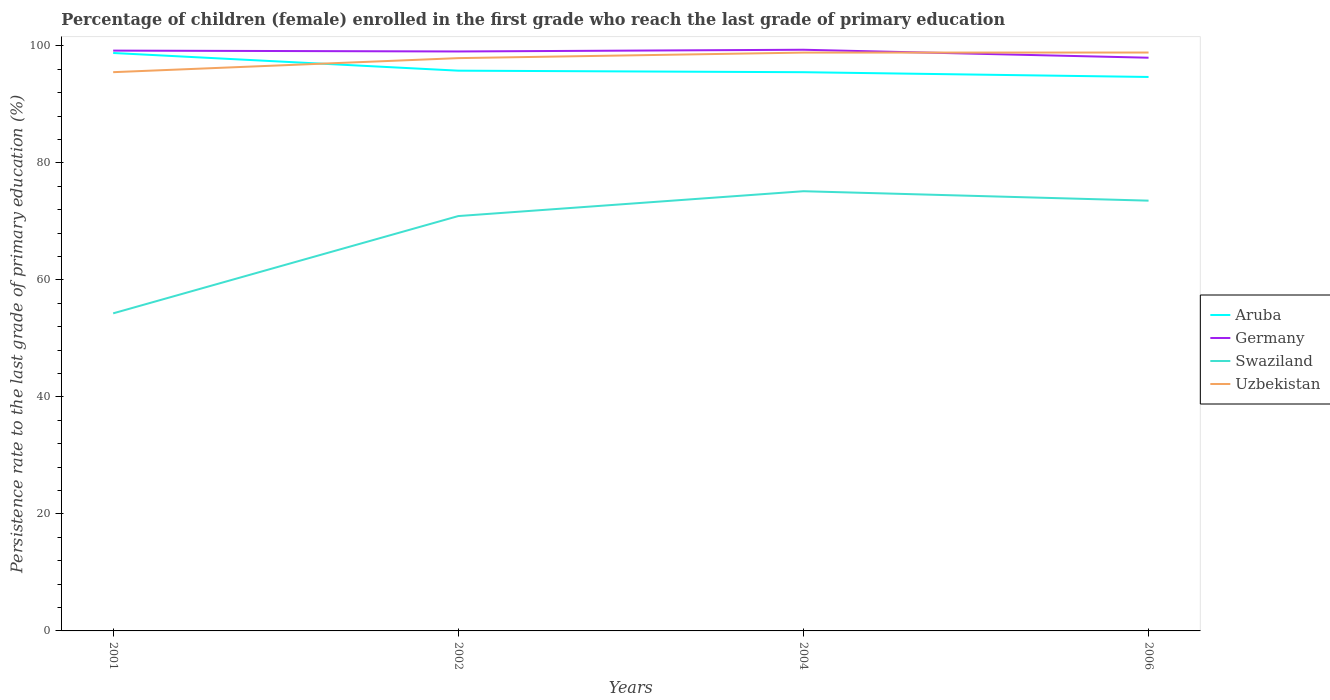Does the line corresponding to Germany intersect with the line corresponding to Aruba?
Your response must be concise. No. Is the number of lines equal to the number of legend labels?
Offer a terse response. Yes. Across all years, what is the maximum persistence rate of children in Swaziland?
Your response must be concise. 54.29. What is the total persistence rate of children in Swaziland in the graph?
Your answer should be compact. -16.63. What is the difference between the highest and the second highest persistence rate of children in Germany?
Offer a very short reply. 1.36. What is the difference between the highest and the lowest persistence rate of children in Aruba?
Ensure brevity in your answer.  1. Is the persistence rate of children in Aruba strictly greater than the persistence rate of children in Germany over the years?
Your response must be concise. Yes. How many years are there in the graph?
Your answer should be very brief. 4. What is the difference between two consecutive major ticks on the Y-axis?
Make the answer very short. 20. Are the values on the major ticks of Y-axis written in scientific E-notation?
Your answer should be compact. No. Does the graph contain any zero values?
Offer a terse response. No. Where does the legend appear in the graph?
Your response must be concise. Center right. How many legend labels are there?
Your answer should be very brief. 4. What is the title of the graph?
Ensure brevity in your answer.  Percentage of children (female) enrolled in the first grade who reach the last grade of primary education. Does "Mauritius" appear as one of the legend labels in the graph?
Give a very brief answer. No. What is the label or title of the X-axis?
Provide a succinct answer. Years. What is the label or title of the Y-axis?
Provide a succinct answer. Persistence rate to the last grade of primary education (%). What is the Persistence rate to the last grade of primary education (%) in Aruba in 2001?
Your answer should be very brief. 98.8. What is the Persistence rate to the last grade of primary education (%) in Germany in 2001?
Your answer should be very brief. 99.2. What is the Persistence rate to the last grade of primary education (%) of Swaziland in 2001?
Provide a succinct answer. 54.29. What is the Persistence rate to the last grade of primary education (%) of Uzbekistan in 2001?
Your response must be concise. 95.51. What is the Persistence rate to the last grade of primary education (%) in Aruba in 2002?
Ensure brevity in your answer.  95.77. What is the Persistence rate to the last grade of primary education (%) of Germany in 2002?
Provide a succinct answer. 99.05. What is the Persistence rate to the last grade of primary education (%) in Swaziland in 2002?
Offer a terse response. 70.92. What is the Persistence rate to the last grade of primary education (%) in Uzbekistan in 2002?
Ensure brevity in your answer.  97.92. What is the Persistence rate to the last grade of primary education (%) in Aruba in 2004?
Provide a succinct answer. 95.51. What is the Persistence rate to the last grade of primary education (%) of Germany in 2004?
Your answer should be compact. 99.35. What is the Persistence rate to the last grade of primary education (%) of Swaziland in 2004?
Your answer should be compact. 75.16. What is the Persistence rate to the last grade of primary education (%) of Uzbekistan in 2004?
Your answer should be compact. 98.86. What is the Persistence rate to the last grade of primary education (%) of Aruba in 2006?
Keep it short and to the point. 94.7. What is the Persistence rate to the last grade of primary education (%) of Germany in 2006?
Provide a short and direct response. 97.99. What is the Persistence rate to the last grade of primary education (%) of Swaziland in 2006?
Offer a terse response. 73.55. What is the Persistence rate to the last grade of primary education (%) in Uzbekistan in 2006?
Offer a very short reply. 98.87. Across all years, what is the maximum Persistence rate to the last grade of primary education (%) of Aruba?
Provide a succinct answer. 98.8. Across all years, what is the maximum Persistence rate to the last grade of primary education (%) of Germany?
Offer a very short reply. 99.35. Across all years, what is the maximum Persistence rate to the last grade of primary education (%) of Swaziland?
Offer a very short reply. 75.16. Across all years, what is the maximum Persistence rate to the last grade of primary education (%) of Uzbekistan?
Offer a very short reply. 98.87. Across all years, what is the minimum Persistence rate to the last grade of primary education (%) of Aruba?
Keep it short and to the point. 94.7. Across all years, what is the minimum Persistence rate to the last grade of primary education (%) in Germany?
Offer a terse response. 97.99. Across all years, what is the minimum Persistence rate to the last grade of primary education (%) of Swaziland?
Give a very brief answer. 54.29. Across all years, what is the minimum Persistence rate to the last grade of primary education (%) in Uzbekistan?
Your answer should be compact. 95.51. What is the total Persistence rate to the last grade of primary education (%) in Aruba in the graph?
Your response must be concise. 384.77. What is the total Persistence rate to the last grade of primary education (%) of Germany in the graph?
Offer a very short reply. 395.59. What is the total Persistence rate to the last grade of primary education (%) in Swaziland in the graph?
Your answer should be very brief. 273.92. What is the total Persistence rate to the last grade of primary education (%) of Uzbekistan in the graph?
Make the answer very short. 391.16. What is the difference between the Persistence rate to the last grade of primary education (%) of Aruba in 2001 and that in 2002?
Ensure brevity in your answer.  3.02. What is the difference between the Persistence rate to the last grade of primary education (%) in Germany in 2001 and that in 2002?
Your response must be concise. 0.14. What is the difference between the Persistence rate to the last grade of primary education (%) in Swaziland in 2001 and that in 2002?
Your answer should be compact. -16.63. What is the difference between the Persistence rate to the last grade of primary education (%) in Uzbekistan in 2001 and that in 2002?
Your response must be concise. -2.4. What is the difference between the Persistence rate to the last grade of primary education (%) in Aruba in 2001 and that in 2004?
Your answer should be very brief. 3.29. What is the difference between the Persistence rate to the last grade of primary education (%) in Germany in 2001 and that in 2004?
Your answer should be compact. -0.15. What is the difference between the Persistence rate to the last grade of primary education (%) in Swaziland in 2001 and that in 2004?
Offer a very short reply. -20.88. What is the difference between the Persistence rate to the last grade of primary education (%) of Uzbekistan in 2001 and that in 2004?
Give a very brief answer. -3.35. What is the difference between the Persistence rate to the last grade of primary education (%) in Aruba in 2001 and that in 2006?
Your answer should be very brief. 4.1. What is the difference between the Persistence rate to the last grade of primary education (%) in Germany in 2001 and that in 2006?
Ensure brevity in your answer.  1.21. What is the difference between the Persistence rate to the last grade of primary education (%) of Swaziland in 2001 and that in 2006?
Ensure brevity in your answer.  -19.27. What is the difference between the Persistence rate to the last grade of primary education (%) in Uzbekistan in 2001 and that in 2006?
Provide a succinct answer. -3.36. What is the difference between the Persistence rate to the last grade of primary education (%) in Aruba in 2002 and that in 2004?
Your response must be concise. 0.26. What is the difference between the Persistence rate to the last grade of primary education (%) in Germany in 2002 and that in 2004?
Offer a terse response. -0.29. What is the difference between the Persistence rate to the last grade of primary education (%) in Swaziland in 2002 and that in 2004?
Your answer should be very brief. -4.25. What is the difference between the Persistence rate to the last grade of primary education (%) of Uzbekistan in 2002 and that in 2004?
Your answer should be compact. -0.94. What is the difference between the Persistence rate to the last grade of primary education (%) in Aruba in 2002 and that in 2006?
Your answer should be compact. 1.08. What is the difference between the Persistence rate to the last grade of primary education (%) in Germany in 2002 and that in 2006?
Offer a terse response. 1.07. What is the difference between the Persistence rate to the last grade of primary education (%) in Swaziland in 2002 and that in 2006?
Offer a very short reply. -2.63. What is the difference between the Persistence rate to the last grade of primary education (%) in Uzbekistan in 2002 and that in 2006?
Your response must be concise. -0.95. What is the difference between the Persistence rate to the last grade of primary education (%) of Aruba in 2004 and that in 2006?
Offer a very short reply. 0.81. What is the difference between the Persistence rate to the last grade of primary education (%) of Germany in 2004 and that in 2006?
Offer a terse response. 1.36. What is the difference between the Persistence rate to the last grade of primary education (%) in Swaziland in 2004 and that in 2006?
Give a very brief answer. 1.61. What is the difference between the Persistence rate to the last grade of primary education (%) of Uzbekistan in 2004 and that in 2006?
Give a very brief answer. -0.01. What is the difference between the Persistence rate to the last grade of primary education (%) of Aruba in 2001 and the Persistence rate to the last grade of primary education (%) of Germany in 2002?
Your answer should be very brief. -0.26. What is the difference between the Persistence rate to the last grade of primary education (%) in Aruba in 2001 and the Persistence rate to the last grade of primary education (%) in Swaziland in 2002?
Provide a succinct answer. 27.88. What is the difference between the Persistence rate to the last grade of primary education (%) of Aruba in 2001 and the Persistence rate to the last grade of primary education (%) of Uzbekistan in 2002?
Provide a short and direct response. 0.88. What is the difference between the Persistence rate to the last grade of primary education (%) in Germany in 2001 and the Persistence rate to the last grade of primary education (%) in Swaziland in 2002?
Give a very brief answer. 28.28. What is the difference between the Persistence rate to the last grade of primary education (%) in Germany in 2001 and the Persistence rate to the last grade of primary education (%) in Uzbekistan in 2002?
Offer a very short reply. 1.28. What is the difference between the Persistence rate to the last grade of primary education (%) of Swaziland in 2001 and the Persistence rate to the last grade of primary education (%) of Uzbekistan in 2002?
Provide a short and direct response. -43.63. What is the difference between the Persistence rate to the last grade of primary education (%) in Aruba in 2001 and the Persistence rate to the last grade of primary education (%) in Germany in 2004?
Provide a succinct answer. -0.55. What is the difference between the Persistence rate to the last grade of primary education (%) in Aruba in 2001 and the Persistence rate to the last grade of primary education (%) in Swaziland in 2004?
Make the answer very short. 23.63. What is the difference between the Persistence rate to the last grade of primary education (%) of Aruba in 2001 and the Persistence rate to the last grade of primary education (%) of Uzbekistan in 2004?
Your answer should be compact. -0.06. What is the difference between the Persistence rate to the last grade of primary education (%) in Germany in 2001 and the Persistence rate to the last grade of primary education (%) in Swaziland in 2004?
Offer a terse response. 24.04. What is the difference between the Persistence rate to the last grade of primary education (%) of Germany in 2001 and the Persistence rate to the last grade of primary education (%) of Uzbekistan in 2004?
Keep it short and to the point. 0.34. What is the difference between the Persistence rate to the last grade of primary education (%) in Swaziland in 2001 and the Persistence rate to the last grade of primary education (%) in Uzbekistan in 2004?
Your response must be concise. -44.57. What is the difference between the Persistence rate to the last grade of primary education (%) of Aruba in 2001 and the Persistence rate to the last grade of primary education (%) of Germany in 2006?
Provide a succinct answer. 0.81. What is the difference between the Persistence rate to the last grade of primary education (%) in Aruba in 2001 and the Persistence rate to the last grade of primary education (%) in Swaziland in 2006?
Provide a short and direct response. 25.24. What is the difference between the Persistence rate to the last grade of primary education (%) of Aruba in 2001 and the Persistence rate to the last grade of primary education (%) of Uzbekistan in 2006?
Ensure brevity in your answer.  -0.08. What is the difference between the Persistence rate to the last grade of primary education (%) of Germany in 2001 and the Persistence rate to the last grade of primary education (%) of Swaziland in 2006?
Make the answer very short. 25.65. What is the difference between the Persistence rate to the last grade of primary education (%) in Germany in 2001 and the Persistence rate to the last grade of primary education (%) in Uzbekistan in 2006?
Ensure brevity in your answer.  0.33. What is the difference between the Persistence rate to the last grade of primary education (%) in Swaziland in 2001 and the Persistence rate to the last grade of primary education (%) in Uzbekistan in 2006?
Your answer should be compact. -44.58. What is the difference between the Persistence rate to the last grade of primary education (%) in Aruba in 2002 and the Persistence rate to the last grade of primary education (%) in Germany in 2004?
Give a very brief answer. -3.58. What is the difference between the Persistence rate to the last grade of primary education (%) of Aruba in 2002 and the Persistence rate to the last grade of primary education (%) of Swaziland in 2004?
Give a very brief answer. 20.61. What is the difference between the Persistence rate to the last grade of primary education (%) of Aruba in 2002 and the Persistence rate to the last grade of primary education (%) of Uzbekistan in 2004?
Offer a very short reply. -3.09. What is the difference between the Persistence rate to the last grade of primary education (%) in Germany in 2002 and the Persistence rate to the last grade of primary education (%) in Swaziland in 2004?
Your answer should be compact. 23.89. What is the difference between the Persistence rate to the last grade of primary education (%) in Germany in 2002 and the Persistence rate to the last grade of primary education (%) in Uzbekistan in 2004?
Give a very brief answer. 0.2. What is the difference between the Persistence rate to the last grade of primary education (%) in Swaziland in 2002 and the Persistence rate to the last grade of primary education (%) in Uzbekistan in 2004?
Provide a short and direct response. -27.94. What is the difference between the Persistence rate to the last grade of primary education (%) of Aruba in 2002 and the Persistence rate to the last grade of primary education (%) of Germany in 2006?
Provide a succinct answer. -2.22. What is the difference between the Persistence rate to the last grade of primary education (%) in Aruba in 2002 and the Persistence rate to the last grade of primary education (%) in Swaziland in 2006?
Give a very brief answer. 22.22. What is the difference between the Persistence rate to the last grade of primary education (%) in Aruba in 2002 and the Persistence rate to the last grade of primary education (%) in Uzbekistan in 2006?
Your answer should be very brief. -3.1. What is the difference between the Persistence rate to the last grade of primary education (%) of Germany in 2002 and the Persistence rate to the last grade of primary education (%) of Swaziland in 2006?
Your answer should be compact. 25.5. What is the difference between the Persistence rate to the last grade of primary education (%) of Germany in 2002 and the Persistence rate to the last grade of primary education (%) of Uzbekistan in 2006?
Give a very brief answer. 0.18. What is the difference between the Persistence rate to the last grade of primary education (%) of Swaziland in 2002 and the Persistence rate to the last grade of primary education (%) of Uzbekistan in 2006?
Your answer should be very brief. -27.95. What is the difference between the Persistence rate to the last grade of primary education (%) in Aruba in 2004 and the Persistence rate to the last grade of primary education (%) in Germany in 2006?
Give a very brief answer. -2.48. What is the difference between the Persistence rate to the last grade of primary education (%) in Aruba in 2004 and the Persistence rate to the last grade of primary education (%) in Swaziland in 2006?
Ensure brevity in your answer.  21.96. What is the difference between the Persistence rate to the last grade of primary education (%) of Aruba in 2004 and the Persistence rate to the last grade of primary education (%) of Uzbekistan in 2006?
Your response must be concise. -3.36. What is the difference between the Persistence rate to the last grade of primary education (%) of Germany in 2004 and the Persistence rate to the last grade of primary education (%) of Swaziland in 2006?
Make the answer very short. 25.79. What is the difference between the Persistence rate to the last grade of primary education (%) in Germany in 2004 and the Persistence rate to the last grade of primary education (%) in Uzbekistan in 2006?
Make the answer very short. 0.48. What is the difference between the Persistence rate to the last grade of primary education (%) of Swaziland in 2004 and the Persistence rate to the last grade of primary education (%) of Uzbekistan in 2006?
Offer a terse response. -23.71. What is the average Persistence rate to the last grade of primary education (%) of Aruba per year?
Keep it short and to the point. 96.19. What is the average Persistence rate to the last grade of primary education (%) in Germany per year?
Keep it short and to the point. 98.9. What is the average Persistence rate to the last grade of primary education (%) of Swaziland per year?
Offer a terse response. 68.48. What is the average Persistence rate to the last grade of primary education (%) of Uzbekistan per year?
Give a very brief answer. 97.79. In the year 2001, what is the difference between the Persistence rate to the last grade of primary education (%) in Aruba and Persistence rate to the last grade of primary education (%) in Germany?
Keep it short and to the point. -0.4. In the year 2001, what is the difference between the Persistence rate to the last grade of primary education (%) in Aruba and Persistence rate to the last grade of primary education (%) in Swaziland?
Give a very brief answer. 44.51. In the year 2001, what is the difference between the Persistence rate to the last grade of primary education (%) of Aruba and Persistence rate to the last grade of primary education (%) of Uzbekistan?
Give a very brief answer. 3.28. In the year 2001, what is the difference between the Persistence rate to the last grade of primary education (%) in Germany and Persistence rate to the last grade of primary education (%) in Swaziland?
Your answer should be compact. 44.91. In the year 2001, what is the difference between the Persistence rate to the last grade of primary education (%) of Germany and Persistence rate to the last grade of primary education (%) of Uzbekistan?
Your answer should be very brief. 3.69. In the year 2001, what is the difference between the Persistence rate to the last grade of primary education (%) in Swaziland and Persistence rate to the last grade of primary education (%) in Uzbekistan?
Provide a succinct answer. -41.23. In the year 2002, what is the difference between the Persistence rate to the last grade of primary education (%) of Aruba and Persistence rate to the last grade of primary education (%) of Germany?
Keep it short and to the point. -3.28. In the year 2002, what is the difference between the Persistence rate to the last grade of primary education (%) of Aruba and Persistence rate to the last grade of primary education (%) of Swaziland?
Your answer should be compact. 24.85. In the year 2002, what is the difference between the Persistence rate to the last grade of primary education (%) of Aruba and Persistence rate to the last grade of primary education (%) of Uzbekistan?
Offer a terse response. -2.15. In the year 2002, what is the difference between the Persistence rate to the last grade of primary education (%) of Germany and Persistence rate to the last grade of primary education (%) of Swaziland?
Your answer should be very brief. 28.14. In the year 2002, what is the difference between the Persistence rate to the last grade of primary education (%) of Germany and Persistence rate to the last grade of primary education (%) of Uzbekistan?
Give a very brief answer. 1.14. In the year 2002, what is the difference between the Persistence rate to the last grade of primary education (%) in Swaziland and Persistence rate to the last grade of primary education (%) in Uzbekistan?
Offer a terse response. -27. In the year 2004, what is the difference between the Persistence rate to the last grade of primary education (%) of Aruba and Persistence rate to the last grade of primary education (%) of Germany?
Give a very brief answer. -3.84. In the year 2004, what is the difference between the Persistence rate to the last grade of primary education (%) of Aruba and Persistence rate to the last grade of primary education (%) of Swaziland?
Your answer should be very brief. 20.35. In the year 2004, what is the difference between the Persistence rate to the last grade of primary education (%) of Aruba and Persistence rate to the last grade of primary education (%) of Uzbekistan?
Your answer should be compact. -3.35. In the year 2004, what is the difference between the Persistence rate to the last grade of primary education (%) in Germany and Persistence rate to the last grade of primary education (%) in Swaziland?
Provide a short and direct response. 24.18. In the year 2004, what is the difference between the Persistence rate to the last grade of primary education (%) in Germany and Persistence rate to the last grade of primary education (%) in Uzbekistan?
Provide a succinct answer. 0.49. In the year 2004, what is the difference between the Persistence rate to the last grade of primary education (%) in Swaziland and Persistence rate to the last grade of primary education (%) in Uzbekistan?
Keep it short and to the point. -23.7. In the year 2006, what is the difference between the Persistence rate to the last grade of primary education (%) in Aruba and Persistence rate to the last grade of primary education (%) in Germany?
Your answer should be compact. -3.29. In the year 2006, what is the difference between the Persistence rate to the last grade of primary education (%) of Aruba and Persistence rate to the last grade of primary education (%) of Swaziland?
Ensure brevity in your answer.  21.14. In the year 2006, what is the difference between the Persistence rate to the last grade of primary education (%) in Aruba and Persistence rate to the last grade of primary education (%) in Uzbekistan?
Your answer should be compact. -4.18. In the year 2006, what is the difference between the Persistence rate to the last grade of primary education (%) in Germany and Persistence rate to the last grade of primary education (%) in Swaziland?
Provide a short and direct response. 24.43. In the year 2006, what is the difference between the Persistence rate to the last grade of primary education (%) of Germany and Persistence rate to the last grade of primary education (%) of Uzbekistan?
Make the answer very short. -0.88. In the year 2006, what is the difference between the Persistence rate to the last grade of primary education (%) in Swaziland and Persistence rate to the last grade of primary education (%) in Uzbekistan?
Offer a terse response. -25.32. What is the ratio of the Persistence rate to the last grade of primary education (%) of Aruba in 2001 to that in 2002?
Your answer should be compact. 1.03. What is the ratio of the Persistence rate to the last grade of primary education (%) in Germany in 2001 to that in 2002?
Your answer should be very brief. 1. What is the ratio of the Persistence rate to the last grade of primary education (%) in Swaziland in 2001 to that in 2002?
Your response must be concise. 0.77. What is the ratio of the Persistence rate to the last grade of primary education (%) of Uzbekistan in 2001 to that in 2002?
Your answer should be compact. 0.98. What is the ratio of the Persistence rate to the last grade of primary education (%) in Aruba in 2001 to that in 2004?
Your answer should be very brief. 1.03. What is the ratio of the Persistence rate to the last grade of primary education (%) of Swaziland in 2001 to that in 2004?
Your answer should be very brief. 0.72. What is the ratio of the Persistence rate to the last grade of primary education (%) in Uzbekistan in 2001 to that in 2004?
Ensure brevity in your answer.  0.97. What is the ratio of the Persistence rate to the last grade of primary education (%) in Aruba in 2001 to that in 2006?
Provide a succinct answer. 1.04. What is the ratio of the Persistence rate to the last grade of primary education (%) in Germany in 2001 to that in 2006?
Your answer should be very brief. 1.01. What is the ratio of the Persistence rate to the last grade of primary education (%) in Swaziland in 2001 to that in 2006?
Your response must be concise. 0.74. What is the ratio of the Persistence rate to the last grade of primary education (%) of Uzbekistan in 2001 to that in 2006?
Offer a very short reply. 0.97. What is the ratio of the Persistence rate to the last grade of primary education (%) in Swaziland in 2002 to that in 2004?
Your answer should be very brief. 0.94. What is the ratio of the Persistence rate to the last grade of primary education (%) in Uzbekistan in 2002 to that in 2004?
Your response must be concise. 0.99. What is the ratio of the Persistence rate to the last grade of primary education (%) of Aruba in 2002 to that in 2006?
Ensure brevity in your answer.  1.01. What is the ratio of the Persistence rate to the last grade of primary education (%) of Germany in 2002 to that in 2006?
Your response must be concise. 1.01. What is the ratio of the Persistence rate to the last grade of primary education (%) in Swaziland in 2002 to that in 2006?
Keep it short and to the point. 0.96. What is the ratio of the Persistence rate to the last grade of primary education (%) in Uzbekistan in 2002 to that in 2006?
Provide a short and direct response. 0.99. What is the ratio of the Persistence rate to the last grade of primary education (%) of Aruba in 2004 to that in 2006?
Your answer should be very brief. 1.01. What is the ratio of the Persistence rate to the last grade of primary education (%) in Germany in 2004 to that in 2006?
Ensure brevity in your answer.  1.01. What is the ratio of the Persistence rate to the last grade of primary education (%) of Swaziland in 2004 to that in 2006?
Ensure brevity in your answer.  1.02. What is the difference between the highest and the second highest Persistence rate to the last grade of primary education (%) in Aruba?
Ensure brevity in your answer.  3.02. What is the difference between the highest and the second highest Persistence rate to the last grade of primary education (%) in Germany?
Provide a succinct answer. 0.15. What is the difference between the highest and the second highest Persistence rate to the last grade of primary education (%) of Swaziland?
Keep it short and to the point. 1.61. What is the difference between the highest and the second highest Persistence rate to the last grade of primary education (%) of Uzbekistan?
Offer a terse response. 0.01. What is the difference between the highest and the lowest Persistence rate to the last grade of primary education (%) in Aruba?
Your answer should be compact. 4.1. What is the difference between the highest and the lowest Persistence rate to the last grade of primary education (%) in Germany?
Provide a short and direct response. 1.36. What is the difference between the highest and the lowest Persistence rate to the last grade of primary education (%) in Swaziland?
Provide a succinct answer. 20.88. What is the difference between the highest and the lowest Persistence rate to the last grade of primary education (%) in Uzbekistan?
Make the answer very short. 3.36. 